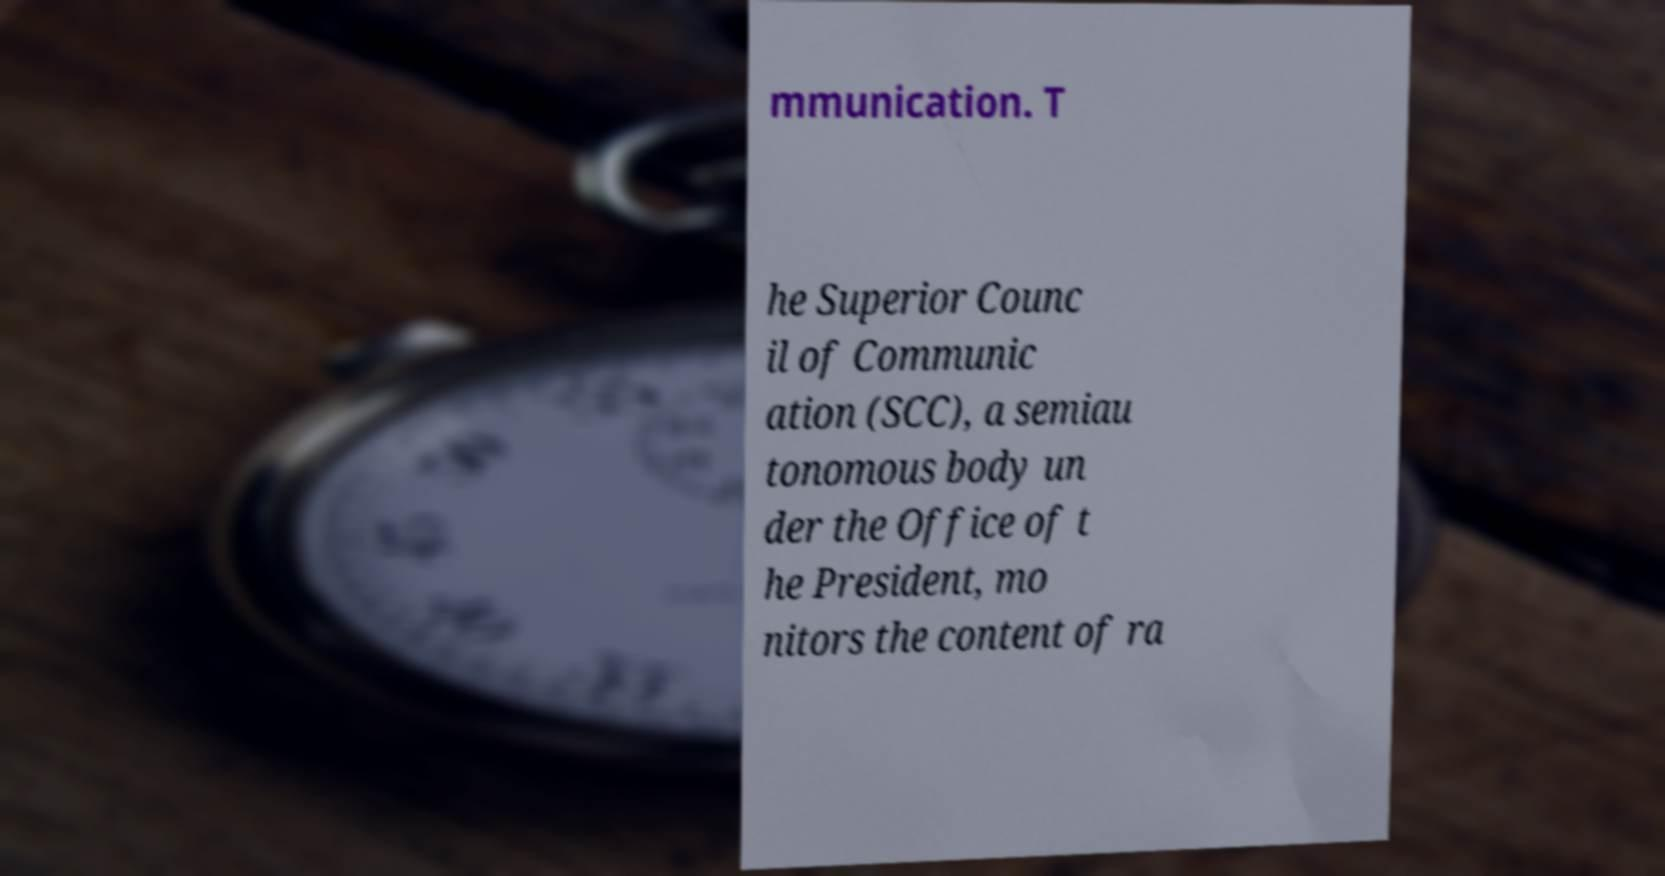Could you assist in decoding the text presented in this image and type it out clearly? mmunication. T he Superior Counc il of Communic ation (SCC), a semiau tonomous body un der the Office of t he President, mo nitors the content of ra 